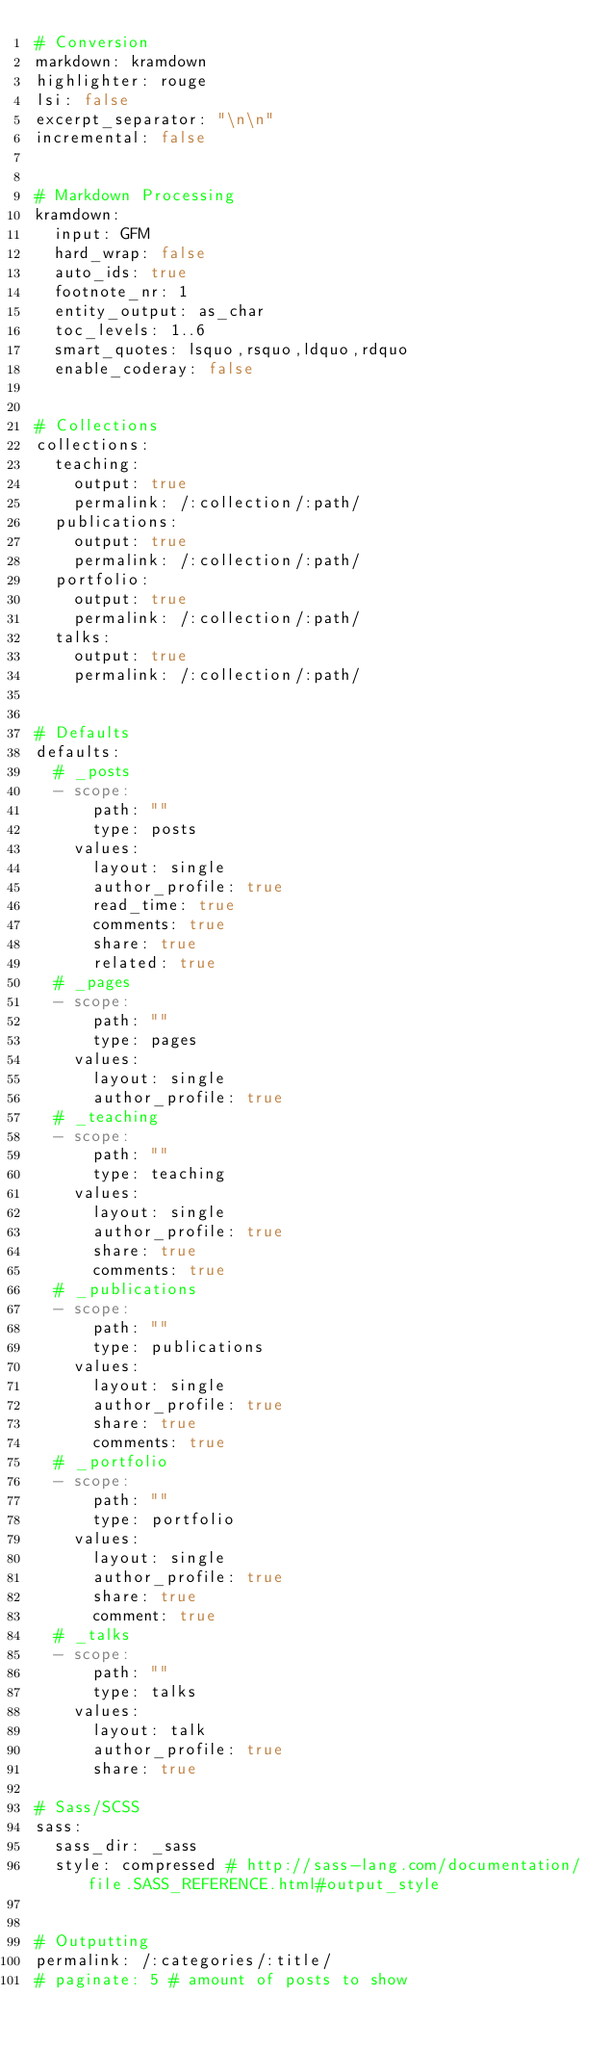Convert code to text. <code><loc_0><loc_0><loc_500><loc_500><_YAML_># Conversion
markdown: kramdown
highlighter: rouge
lsi: false
excerpt_separator: "\n\n"
incremental: false


# Markdown Processing
kramdown:
  input: GFM
  hard_wrap: false
  auto_ids: true
  footnote_nr: 1
  entity_output: as_char
  toc_levels: 1..6
  smart_quotes: lsquo,rsquo,ldquo,rdquo
  enable_coderay: false


# Collections
collections:
  teaching:
    output: true
    permalink: /:collection/:path/
  publications:
    output: true
    permalink: /:collection/:path/
  portfolio:
    output: true
    permalink: /:collection/:path/
  talks:
    output: true
    permalink: /:collection/:path/


# Defaults
defaults:
  # _posts
  - scope:
      path: ""
      type: posts
    values:
      layout: single
      author_profile: true
      read_time: true
      comments: true
      share: true
      related: true
  # _pages
  - scope:
      path: ""
      type: pages
    values:
      layout: single
      author_profile: true
  # _teaching
  - scope:
      path: ""
      type: teaching
    values:
      layout: single
      author_profile: true
      share: true
      comments: true
  # _publications
  - scope:
      path: ""
      type: publications
    values:
      layout: single
      author_profile: true
      share: true
      comments: true
  # _portfolio
  - scope:
      path: ""
      type: portfolio
    values:
      layout: single
      author_profile: true
      share: true
      comment: true
  # _talks
  - scope:
      path: ""
      type: talks
    values:
      layout: talk
      author_profile: true
      share: true

# Sass/SCSS
sass:
  sass_dir: _sass
  style: compressed # http://sass-lang.com/documentation/file.SASS_REFERENCE.html#output_style


# Outputting
permalink: /:categories/:title/
# paginate: 5 # amount of posts to show</code> 